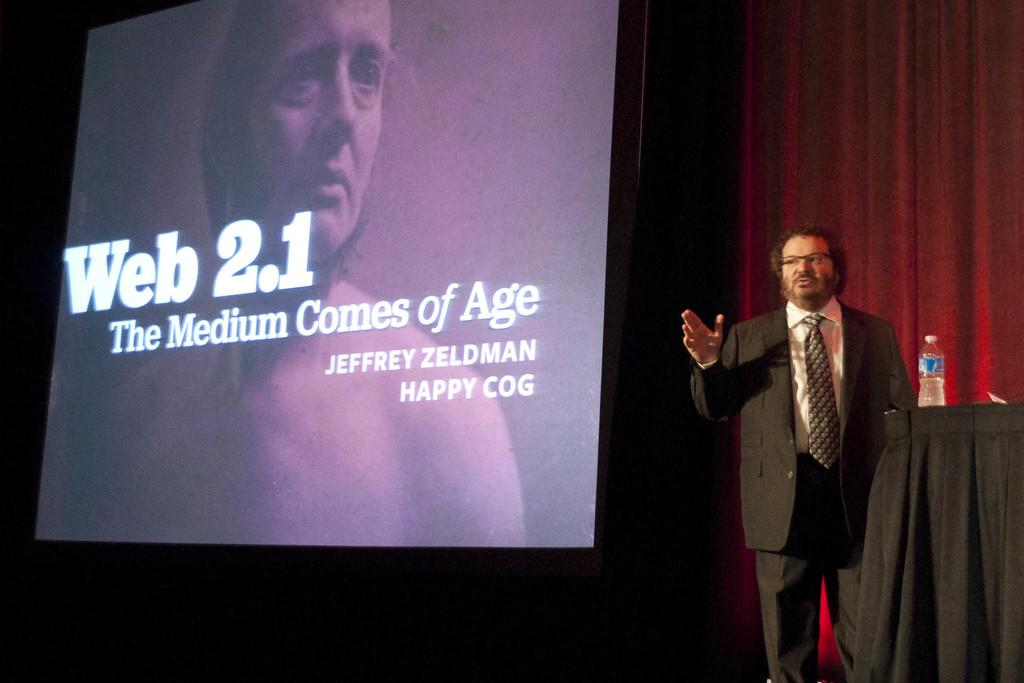Who is present in the image? There is a man in the image. What type of object can be seen in the image? There is cloth, a bottle, and a curtain in the image. What is the purpose of the screen in the image? A person is visible on the screen, which suggests it might be a television or monitor. What can be seen on the screen besides the person? There is text on the screen. What type of writing can be seen on the cloth in the image? There is no writing visible on the cloth in the image. What does the curtain smell like in the image? The image does not provide any information about the scent of the curtain. 